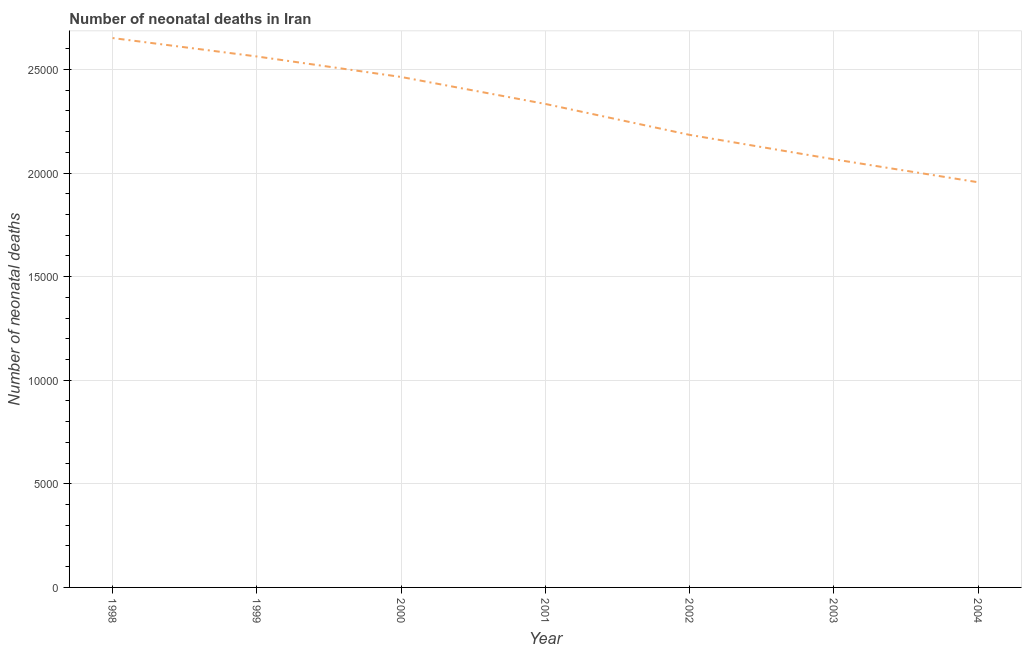What is the number of neonatal deaths in 2003?
Your answer should be compact. 2.07e+04. Across all years, what is the maximum number of neonatal deaths?
Provide a succinct answer. 2.65e+04. Across all years, what is the minimum number of neonatal deaths?
Make the answer very short. 1.96e+04. What is the sum of the number of neonatal deaths?
Provide a short and direct response. 1.62e+05. What is the difference between the number of neonatal deaths in 1999 and 2004?
Your answer should be compact. 6071. What is the average number of neonatal deaths per year?
Offer a terse response. 2.32e+04. What is the median number of neonatal deaths?
Keep it short and to the point. 2.33e+04. Do a majority of the years between 2001 and 2003 (inclusive) have number of neonatal deaths greater than 18000 ?
Keep it short and to the point. Yes. What is the ratio of the number of neonatal deaths in 2003 to that in 2004?
Offer a very short reply. 1.06. Is the number of neonatal deaths in 1998 less than that in 2004?
Your answer should be compact. No. What is the difference between the highest and the second highest number of neonatal deaths?
Provide a succinct answer. 890. What is the difference between the highest and the lowest number of neonatal deaths?
Offer a terse response. 6961. In how many years, is the number of neonatal deaths greater than the average number of neonatal deaths taken over all years?
Your response must be concise. 4. Does the number of neonatal deaths monotonically increase over the years?
Your answer should be compact. No. How many lines are there?
Give a very brief answer. 1. What is the difference between two consecutive major ticks on the Y-axis?
Your answer should be very brief. 5000. Are the values on the major ticks of Y-axis written in scientific E-notation?
Your answer should be very brief. No. Does the graph contain any zero values?
Your answer should be compact. No. Does the graph contain grids?
Make the answer very short. Yes. What is the title of the graph?
Provide a short and direct response. Number of neonatal deaths in Iran. What is the label or title of the Y-axis?
Offer a very short reply. Number of neonatal deaths. What is the Number of neonatal deaths of 1998?
Offer a terse response. 2.65e+04. What is the Number of neonatal deaths in 1999?
Your answer should be very brief. 2.56e+04. What is the Number of neonatal deaths in 2000?
Keep it short and to the point. 2.46e+04. What is the Number of neonatal deaths in 2001?
Offer a very short reply. 2.33e+04. What is the Number of neonatal deaths of 2002?
Provide a succinct answer. 2.18e+04. What is the Number of neonatal deaths in 2003?
Your answer should be compact. 2.07e+04. What is the Number of neonatal deaths in 2004?
Your answer should be very brief. 1.96e+04. What is the difference between the Number of neonatal deaths in 1998 and 1999?
Your answer should be compact. 890. What is the difference between the Number of neonatal deaths in 1998 and 2000?
Offer a very short reply. 1879. What is the difference between the Number of neonatal deaths in 1998 and 2001?
Provide a succinct answer. 3181. What is the difference between the Number of neonatal deaths in 1998 and 2002?
Provide a succinct answer. 4674. What is the difference between the Number of neonatal deaths in 1998 and 2003?
Make the answer very short. 5853. What is the difference between the Number of neonatal deaths in 1998 and 2004?
Ensure brevity in your answer.  6961. What is the difference between the Number of neonatal deaths in 1999 and 2000?
Offer a terse response. 989. What is the difference between the Number of neonatal deaths in 1999 and 2001?
Make the answer very short. 2291. What is the difference between the Number of neonatal deaths in 1999 and 2002?
Provide a short and direct response. 3784. What is the difference between the Number of neonatal deaths in 1999 and 2003?
Keep it short and to the point. 4963. What is the difference between the Number of neonatal deaths in 1999 and 2004?
Your answer should be compact. 6071. What is the difference between the Number of neonatal deaths in 2000 and 2001?
Your response must be concise. 1302. What is the difference between the Number of neonatal deaths in 2000 and 2002?
Offer a very short reply. 2795. What is the difference between the Number of neonatal deaths in 2000 and 2003?
Offer a terse response. 3974. What is the difference between the Number of neonatal deaths in 2000 and 2004?
Your answer should be compact. 5082. What is the difference between the Number of neonatal deaths in 2001 and 2002?
Your response must be concise. 1493. What is the difference between the Number of neonatal deaths in 2001 and 2003?
Ensure brevity in your answer.  2672. What is the difference between the Number of neonatal deaths in 2001 and 2004?
Keep it short and to the point. 3780. What is the difference between the Number of neonatal deaths in 2002 and 2003?
Your response must be concise. 1179. What is the difference between the Number of neonatal deaths in 2002 and 2004?
Your answer should be compact. 2287. What is the difference between the Number of neonatal deaths in 2003 and 2004?
Your response must be concise. 1108. What is the ratio of the Number of neonatal deaths in 1998 to that in 1999?
Give a very brief answer. 1.03. What is the ratio of the Number of neonatal deaths in 1998 to that in 2000?
Give a very brief answer. 1.08. What is the ratio of the Number of neonatal deaths in 1998 to that in 2001?
Ensure brevity in your answer.  1.14. What is the ratio of the Number of neonatal deaths in 1998 to that in 2002?
Your answer should be compact. 1.21. What is the ratio of the Number of neonatal deaths in 1998 to that in 2003?
Keep it short and to the point. 1.28. What is the ratio of the Number of neonatal deaths in 1998 to that in 2004?
Ensure brevity in your answer.  1.36. What is the ratio of the Number of neonatal deaths in 1999 to that in 2001?
Offer a very short reply. 1.1. What is the ratio of the Number of neonatal deaths in 1999 to that in 2002?
Your answer should be very brief. 1.17. What is the ratio of the Number of neonatal deaths in 1999 to that in 2003?
Keep it short and to the point. 1.24. What is the ratio of the Number of neonatal deaths in 1999 to that in 2004?
Provide a succinct answer. 1.31. What is the ratio of the Number of neonatal deaths in 2000 to that in 2001?
Keep it short and to the point. 1.06. What is the ratio of the Number of neonatal deaths in 2000 to that in 2002?
Keep it short and to the point. 1.13. What is the ratio of the Number of neonatal deaths in 2000 to that in 2003?
Make the answer very short. 1.19. What is the ratio of the Number of neonatal deaths in 2000 to that in 2004?
Your response must be concise. 1.26. What is the ratio of the Number of neonatal deaths in 2001 to that in 2002?
Keep it short and to the point. 1.07. What is the ratio of the Number of neonatal deaths in 2001 to that in 2003?
Offer a terse response. 1.13. What is the ratio of the Number of neonatal deaths in 2001 to that in 2004?
Give a very brief answer. 1.19. What is the ratio of the Number of neonatal deaths in 2002 to that in 2003?
Give a very brief answer. 1.06. What is the ratio of the Number of neonatal deaths in 2002 to that in 2004?
Ensure brevity in your answer.  1.12. What is the ratio of the Number of neonatal deaths in 2003 to that in 2004?
Your answer should be very brief. 1.06. 